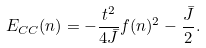<formula> <loc_0><loc_0><loc_500><loc_500>E _ { C C } ( n ) = - \frac { t ^ { 2 } } { 4 { \bar { J } } } f ( n ) ^ { 2 } - \frac { \bar { J } } { 2 } .</formula> 